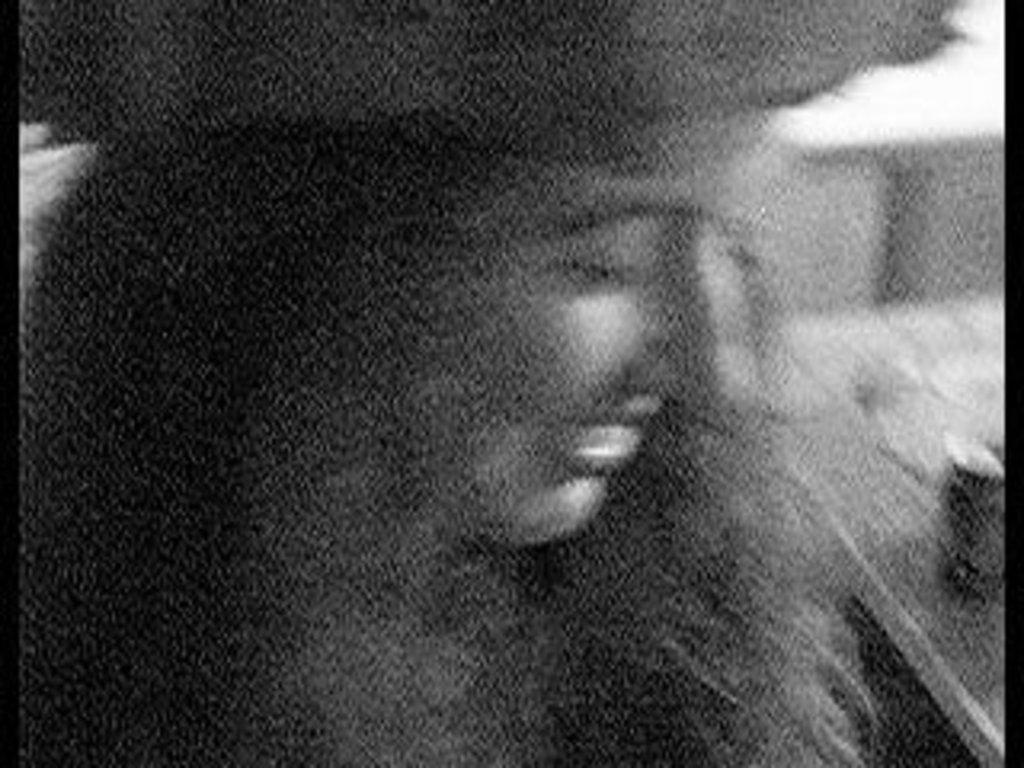Please provide a concise description of this image. In this image there is a lady. The picture is hazy. 